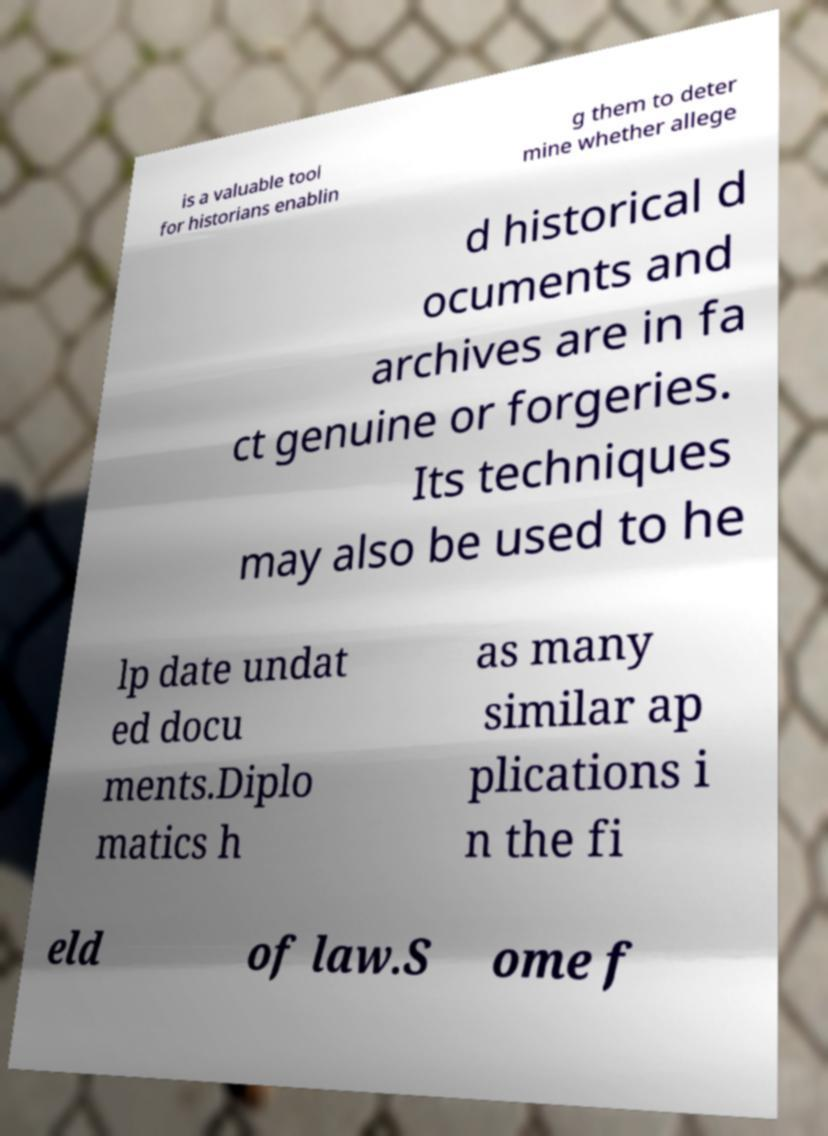Please read and relay the text visible in this image. What does it say? is a valuable tool for historians enablin g them to deter mine whether allege d historical d ocuments and archives are in fa ct genuine or forgeries. Its techniques may also be used to he lp date undat ed docu ments.Diplo matics h as many similar ap plications i n the fi eld of law.S ome f 